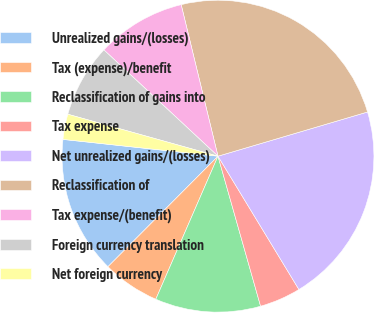Convert chart to OTSL. <chart><loc_0><loc_0><loc_500><loc_500><pie_chart><fcel>Unrealized gains/(losses)<fcel>Tax (expense)/benefit<fcel>Reclassification of gains into<fcel>Tax expense<fcel>Net unrealized gains/(losses)<fcel>Reclassification of<fcel>Tax expense/(benefit)<fcel>Foreign currency translation<fcel>Net foreign currency<nl><fcel>14.25%<fcel>5.94%<fcel>10.93%<fcel>4.28%<fcel>20.89%<fcel>24.22%<fcel>9.27%<fcel>7.6%<fcel>2.62%<nl></chart> 